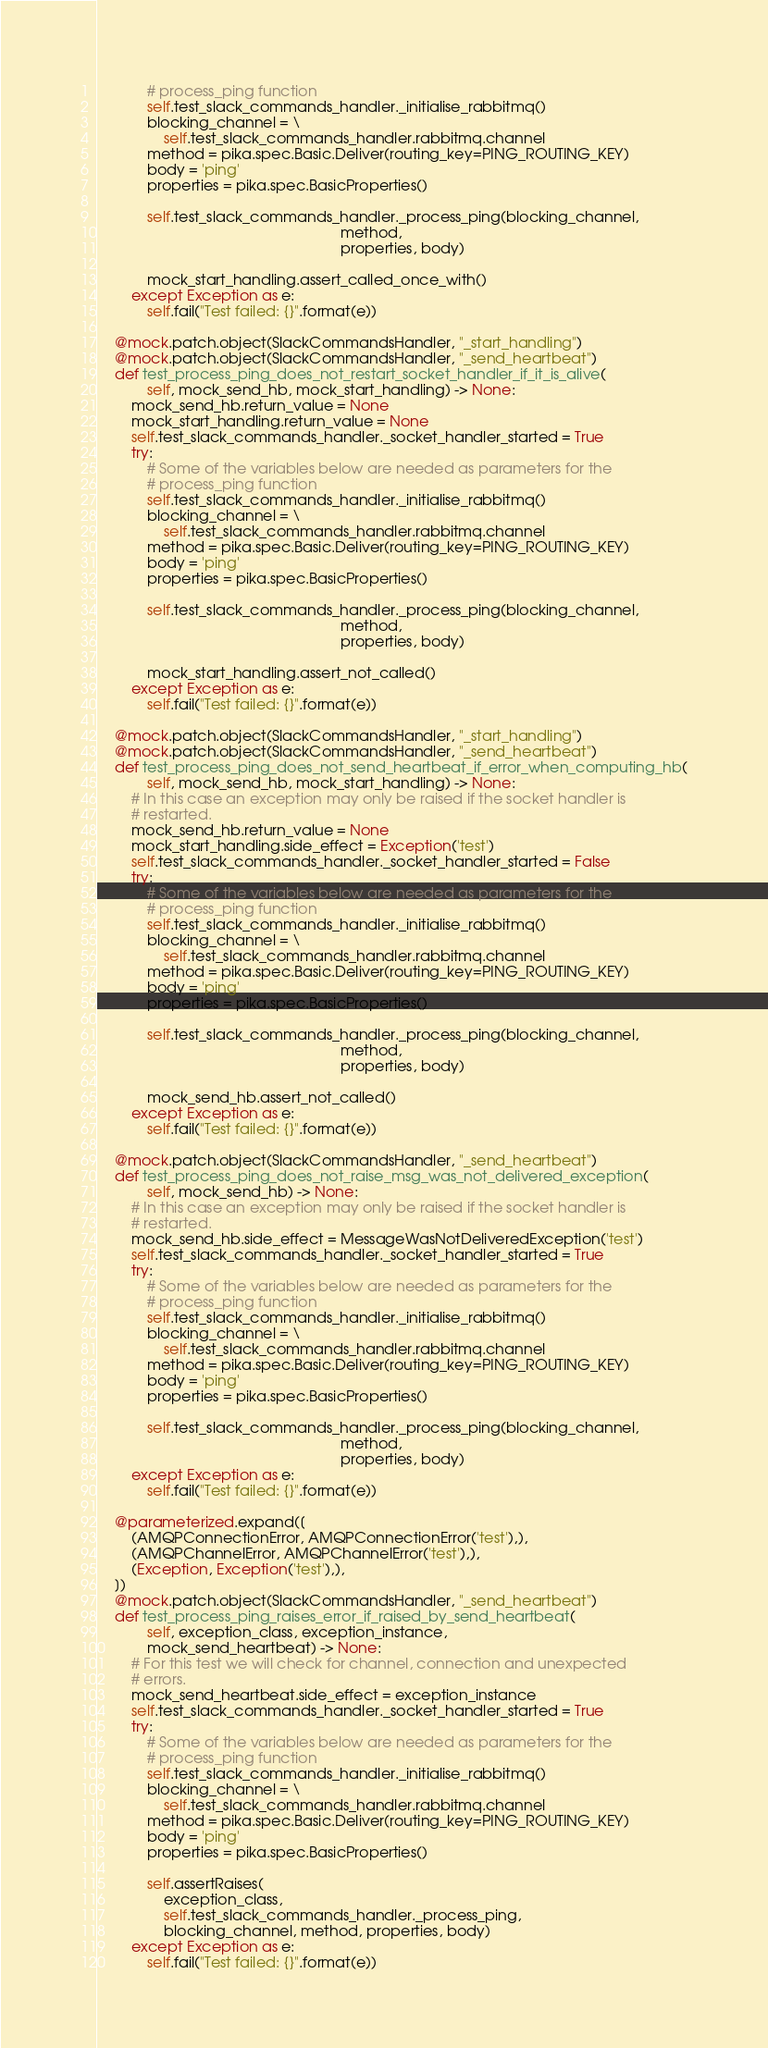<code> <loc_0><loc_0><loc_500><loc_500><_Python_>            # process_ping function
            self.test_slack_commands_handler._initialise_rabbitmq()
            blocking_channel = \
                self.test_slack_commands_handler.rabbitmq.channel
            method = pika.spec.Basic.Deliver(routing_key=PING_ROUTING_KEY)
            body = 'ping'
            properties = pika.spec.BasicProperties()

            self.test_slack_commands_handler._process_ping(blocking_channel,
                                                           method,
                                                           properties, body)

            mock_start_handling.assert_called_once_with()
        except Exception as e:
            self.fail("Test failed: {}".format(e))

    @mock.patch.object(SlackCommandsHandler, "_start_handling")
    @mock.patch.object(SlackCommandsHandler, "_send_heartbeat")
    def test_process_ping_does_not_restart_socket_handler_if_it_is_alive(
            self, mock_send_hb, mock_start_handling) -> None:
        mock_send_hb.return_value = None
        mock_start_handling.return_value = None
        self.test_slack_commands_handler._socket_handler_started = True
        try:
            # Some of the variables below are needed as parameters for the
            # process_ping function
            self.test_slack_commands_handler._initialise_rabbitmq()
            blocking_channel = \
                self.test_slack_commands_handler.rabbitmq.channel
            method = pika.spec.Basic.Deliver(routing_key=PING_ROUTING_KEY)
            body = 'ping'
            properties = pika.spec.BasicProperties()

            self.test_slack_commands_handler._process_ping(blocking_channel,
                                                           method,
                                                           properties, body)

            mock_start_handling.assert_not_called()
        except Exception as e:
            self.fail("Test failed: {}".format(e))

    @mock.patch.object(SlackCommandsHandler, "_start_handling")
    @mock.patch.object(SlackCommandsHandler, "_send_heartbeat")
    def test_process_ping_does_not_send_heartbeat_if_error_when_computing_hb(
            self, mock_send_hb, mock_start_handling) -> None:
        # In this case an exception may only be raised if the socket handler is
        # restarted.
        mock_send_hb.return_value = None
        mock_start_handling.side_effect = Exception('test')
        self.test_slack_commands_handler._socket_handler_started = False
        try:
            # Some of the variables below are needed as parameters for the
            # process_ping function
            self.test_slack_commands_handler._initialise_rabbitmq()
            blocking_channel = \
                self.test_slack_commands_handler.rabbitmq.channel
            method = pika.spec.Basic.Deliver(routing_key=PING_ROUTING_KEY)
            body = 'ping'
            properties = pika.spec.BasicProperties()

            self.test_slack_commands_handler._process_ping(blocking_channel,
                                                           method,
                                                           properties, body)

            mock_send_hb.assert_not_called()
        except Exception as e:
            self.fail("Test failed: {}".format(e))

    @mock.patch.object(SlackCommandsHandler, "_send_heartbeat")
    def test_process_ping_does_not_raise_msg_was_not_delivered_exception(
            self, mock_send_hb) -> None:
        # In this case an exception may only be raised if the socket handler is
        # restarted.
        mock_send_hb.side_effect = MessageWasNotDeliveredException('test')
        self.test_slack_commands_handler._socket_handler_started = True
        try:
            # Some of the variables below are needed as parameters for the
            # process_ping function
            self.test_slack_commands_handler._initialise_rabbitmq()
            blocking_channel = \
                self.test_slack_commands_handler.rabbitmq.channel
            method = pika.spec.Basic.Deliver(routing_key=PING_ROUTING_KEY)
            body = 'ping'
            properties = pika.spec.BasicProperties()

            self.test_slack_commands_handler._process_ping(blocking_channel,
                                                           method,
                                                           properties, body)
        except Exception as e:
            self.fail("Test failed: {}".format(e))

    @parameterized.expand([
        (AMQPConnectionError, AMQPConnectionError('test'),),
        (AMQPChannelError, AMQPChannelError('test'),),
        (Exception, Exception('test'),),
    ])
    @mock.patch.object(SlackCommandsHandler, "_send_heartbeat")
    def test_process_ping_raises_error_if_raised_by_send_heartbeat(
            self, exception_class, exception_instance,
            mock_send_heartbeat) -> None:
        # For this test we will check for channel, connection and unexpected
        # errors.
        mock_send_heartbeat.side_effect = exception_instance
        self.test_slack_commands_handler._socket_handler_started = True
        try:
            # Some of the variables below are needed as parameters for the
            # process_ping function
            self.test_slack_commands_handler._initialise_rabbitmq()
            blocking_channel = \
                self.test_slack_commands_handler.rabbitmq.channel
            method = pika.spec.Basic.Deliver(routing_key=PING_ROUTING_KEY)
            body = 'ping'
            properties = pika.spec.BasicProperties()

            self.assertRaises(
                exception_class,
                self.test_slack_commands_handler._process_ping,
                blocking_channel, method, properties, body)
        except Exception as e:
            self.fail("Test failed: {}".format(e))
</code> 